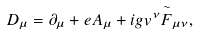<formula> <loc_0><loc_0><loc_500><loc_500>D _ { \mu } = \partial _ { \mu } + e A _ { \mu } + i g v ^ { \nu } \overset { \sim } { F } _ { \mu \nu } ,</formula> 